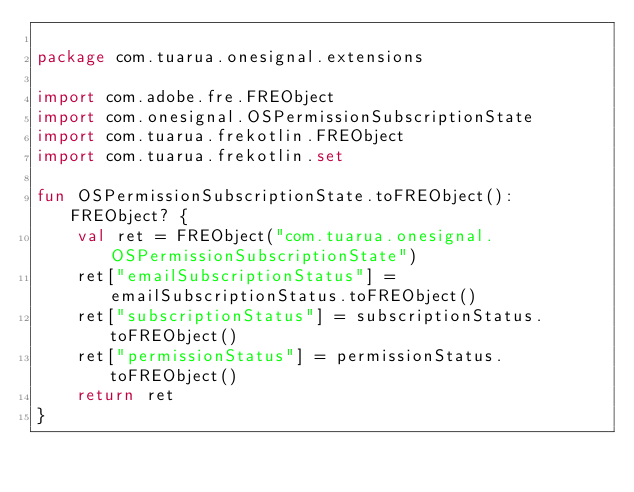Convert code to text. <code><loc_0><loc_0><loc_500><loc_500><_Kotlin_>
package com.tuarua.onesignal.extensions

import com.adobe.fre.FREObject
import com.onesignal.OSPermissionSubscriptionState
import com.tuarua.frekotlin.FREObject
import com.tuarua.frekotlin.set

fun OSPermissionSubscriptionState.toFREObject(): FREObject? {
    val ret = FREObject("com.tuarua.onesignal.OSPermissionSubscriptionState")
    ret["emailSubscriptionStatus"] = emailSubscriptionStatus.toFREObject()
    ret["subscriptionStatus"] = subscriptionStatus.toFREObject()
    ret["permissionStatus"] = permissionStatus.toFREObject()
    return ret
}


</code> 